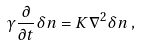<formula> <loc_0><loc_0><loc_500><loc_500>\gamma \frac { \partial } { \partial t } \delta { n } = K \nabla ^ { 2 } \delta { n } \, ,</formula> 